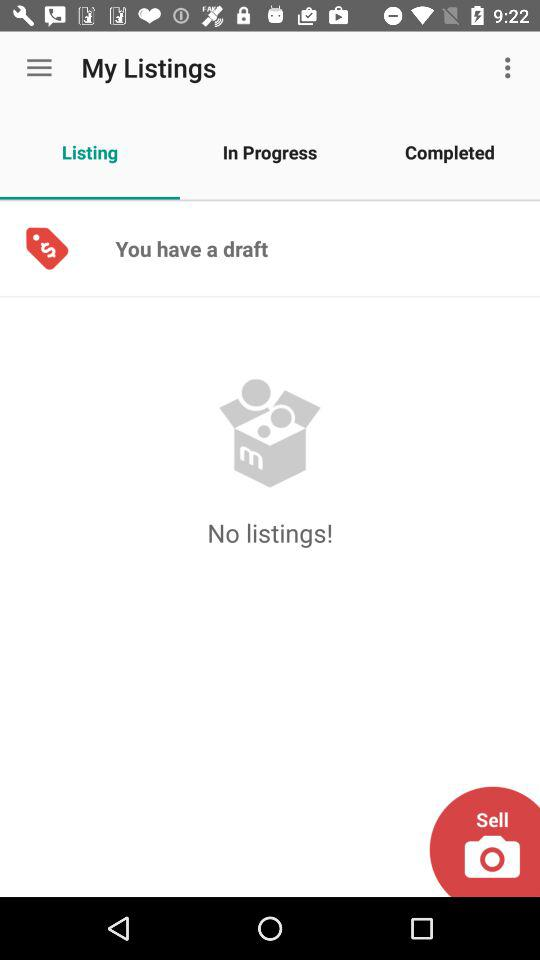Which tab is selected? The selected tab is "Listing". 